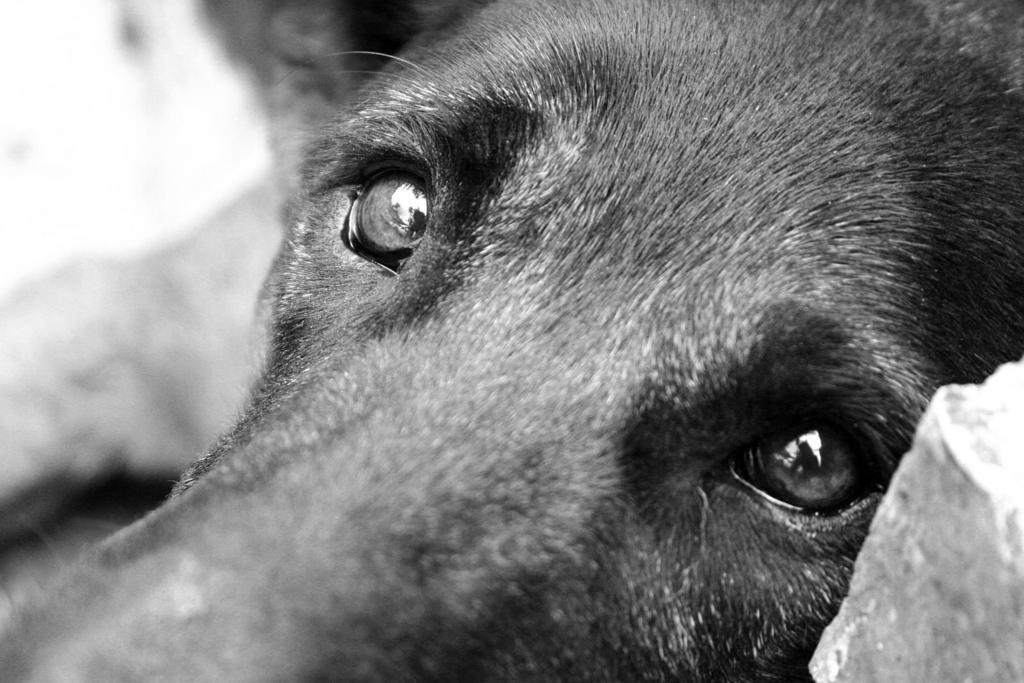What is the focus of the image? The image is zoomed in, so the focus is on a specific area or subject. What can be seen in the foreground of the image? There is an animal in the foreground of the image, which appears to be a dog. How would you describe the background of the image? The background of the image is blurry. What type of gold jewelry is the dog wearing in the image? There is no gold jewelry visible on the dog in the image. How does the snail move across the dog's fur in the image? There is no snail present in the image, so it cannot be determined how a snail might move across the dog's fur. 